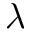Convert formula to latex. <formula><loc_0><loc_0><loc_500><loc_500>\lambda</formula> 